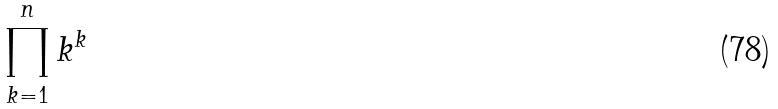<formula> <loc_0><loc_0><loc_500><loc_500>\prod _ { k = 1 } ^ { n } k ^ { k }</formula> 